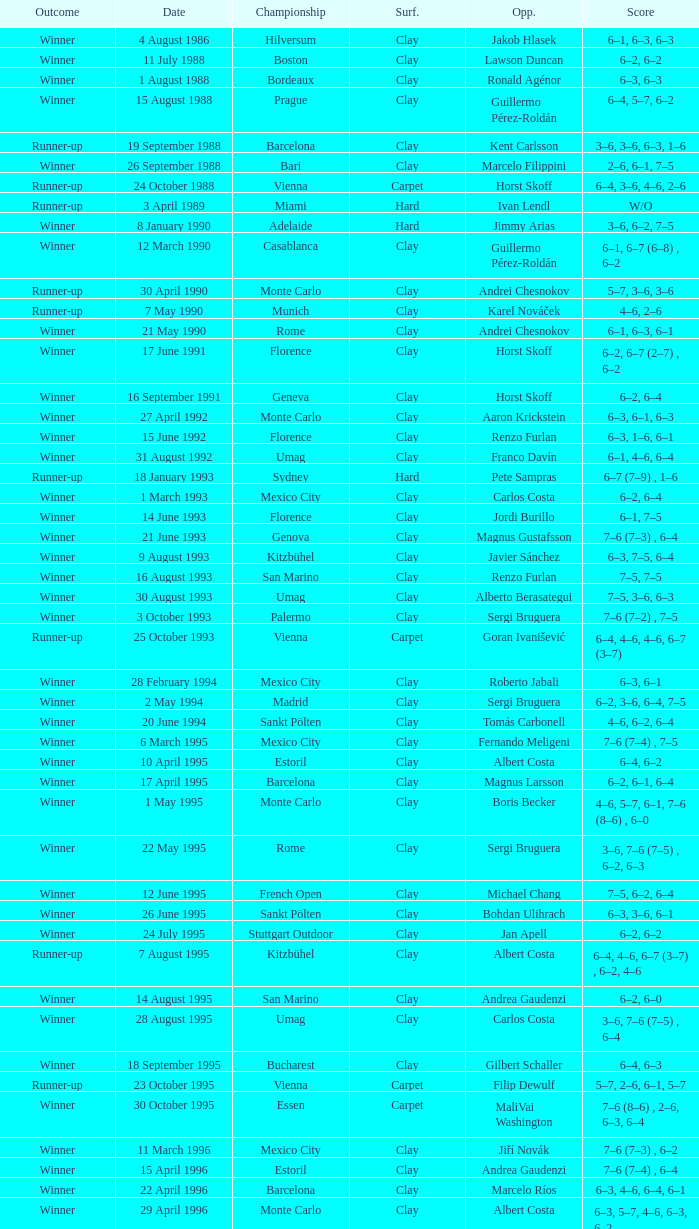Who is the opponent when the surface is clay, the outcome is winner and the championship is estoril on 15 april 1996? Andrea Gaudenzi. 